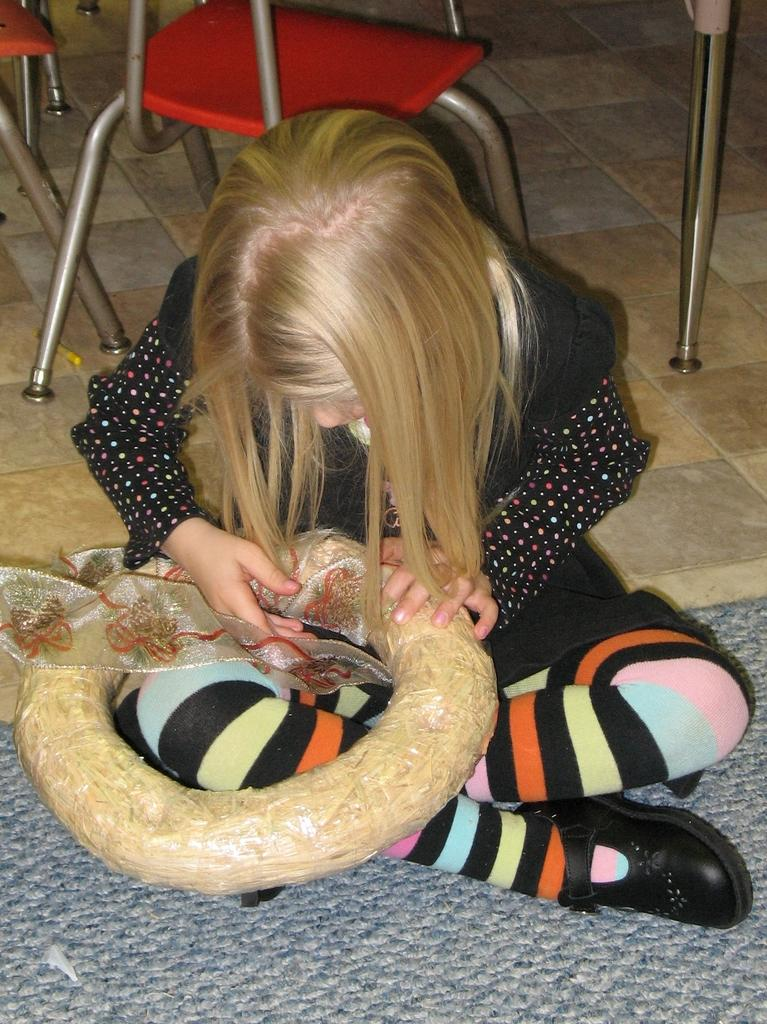Who is the main subject in the picture? There is a girl in the picture. What is the girl doing in the image? The girl is sitting. What is located at the bottom of the image? There is a mat at the bottom of the image. Are there any other objects or furniture in the image? Yes, there are chairs in the image. What type of bait is the girl using to catch fish in the image? There is no bait or fishing activity present in the image. Can you tell me how many shoes the girl is wearing in the image? The image does not show the girl's feet or any shoes she might be wearing. 